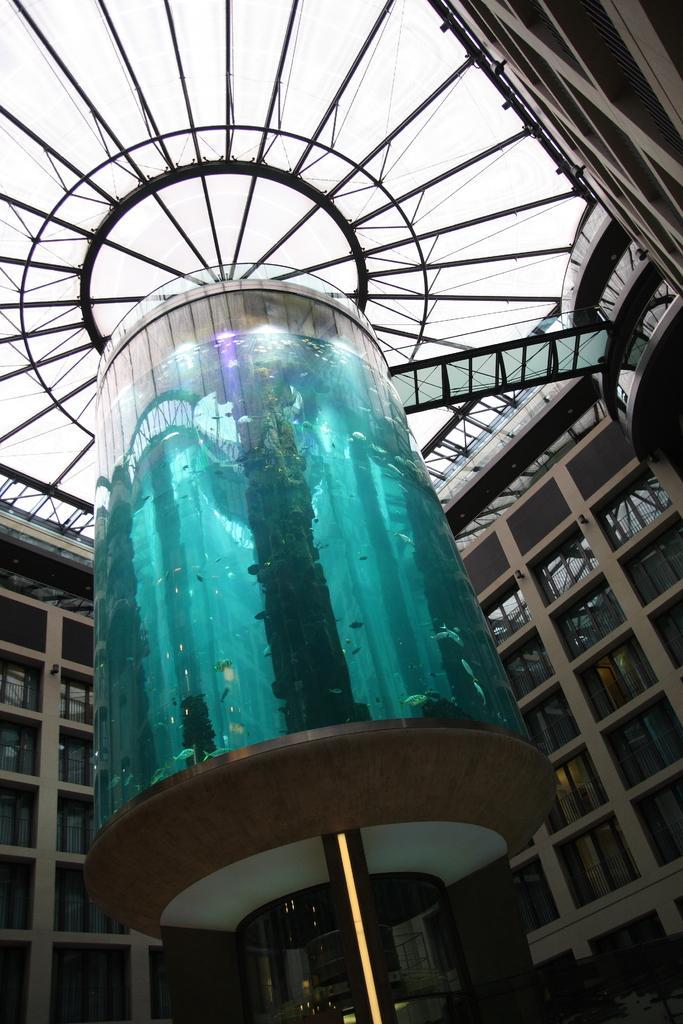Describe this image in one or two sentences. In the middle of the image, there is a glass item. In the background, there is a building which is having glass windows, there is a roof and there is sky. 